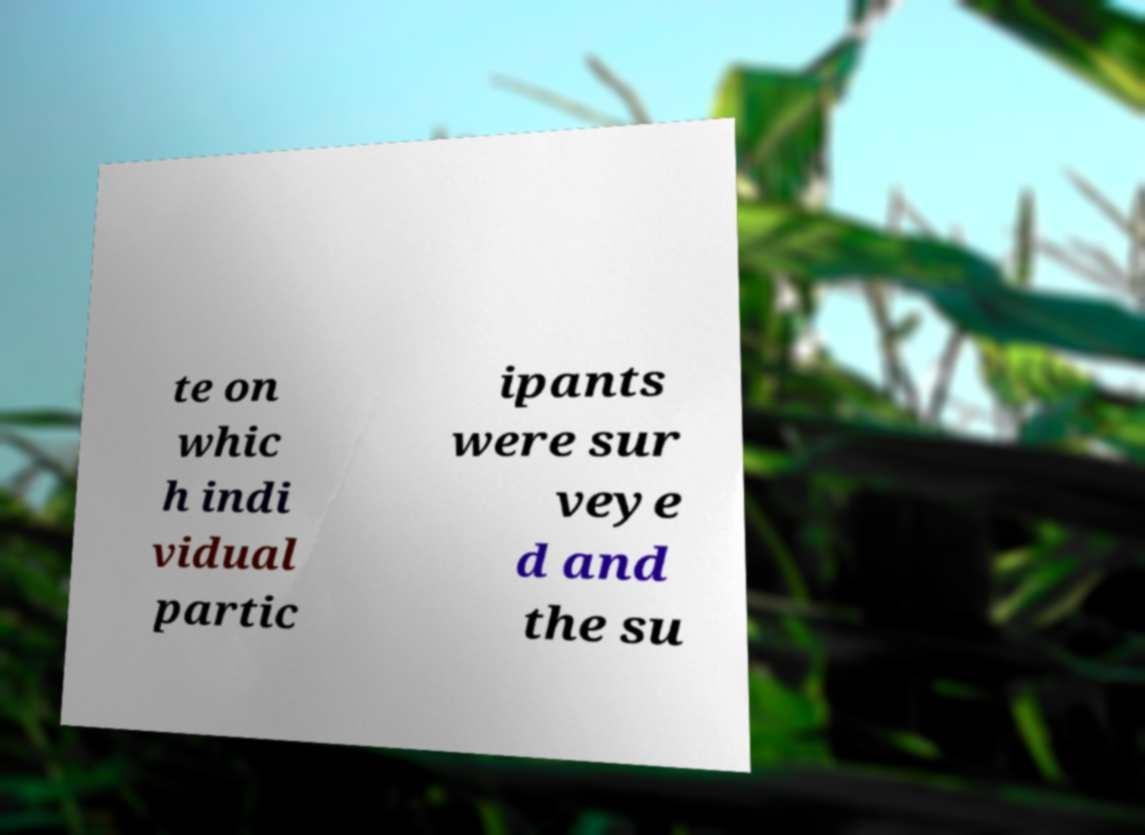There's text embedded in this image that I need extracted. Can you transcribe it verbatim? te on whic h indi vidual partic ipants were sur veye d and the su 